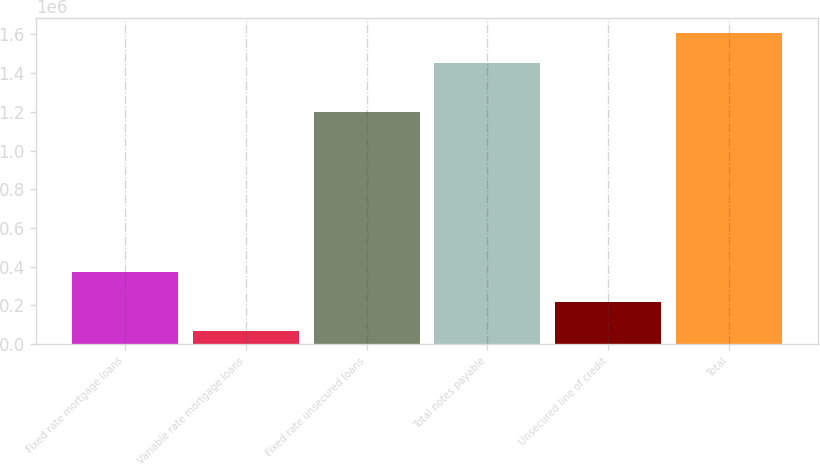Convert chart to OTSL. <chart><loc_0><loc_0><loc_500><loc_500><bar_chart><fcel>Fixed rate mortgage loans<fcel>Variable rate mortgage loans<fcel>Fixed rate unsecured loans<fcel>Total notes payable<fcel>Unsecured line of credit<fcel>Total<nl><fcel>370007<fcel>68662<fcel>1.19883e+06<fcel>1.45439e+06<fcel>219334<fcel>1.60506e+06<nl></chart> 